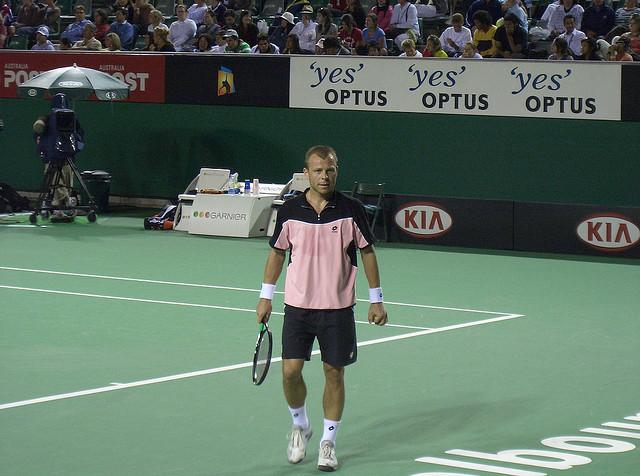What is this man doing wearing a pink shirt?
Write a very short answer. Playing tennis. Are the spectator seats filled to capacity?
Be succinct. Yes. What is written on opposite board of the person standing?
Write a very short answer. Kia. What color is the tennis court?
Give a very brief answer. Green. Is the player wearing black shorts?
Short answer required. Yes. Is the tennis player waiting to hit the ball?
Give a very brief answer. No. What type of surface is the player playing on?
Quick response, please. Tennis court. What sport is this?
Keep it brief. Tennis. Is the man stepping on the line?
Be succinct. No. How many people are in the front row in this picture?
Short answer required. 20. What car brand is a sponsor?
Quick response, please. Kia. What color is the court?
Concise answer only. Green. What color is the surface?
Write a very short answer. Green. Is the tennis player holding proper form to hit the ball?
Be succinct. No. 